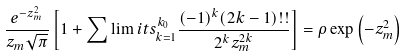Convert formula to latex. <formula><loc_0><loc_0><loc_500><loc_500>\frac { e ^ { - z _ { m } ^ { 2 } } } { z _ { m } \sqrt { \pi } } \left [ 1 + \sum \lim i t s _ { k = 1 } ^ { k _ { 0 } } \frac { ( - 1 ) ^ { k } ( 2 k - 1 ) ! ! } { 2 ^ { k } z _ { m } ^ { 2 k } } \right ] = \rho \exp \left ( - z _ { m } ^ { 2 } \right )</formula> 